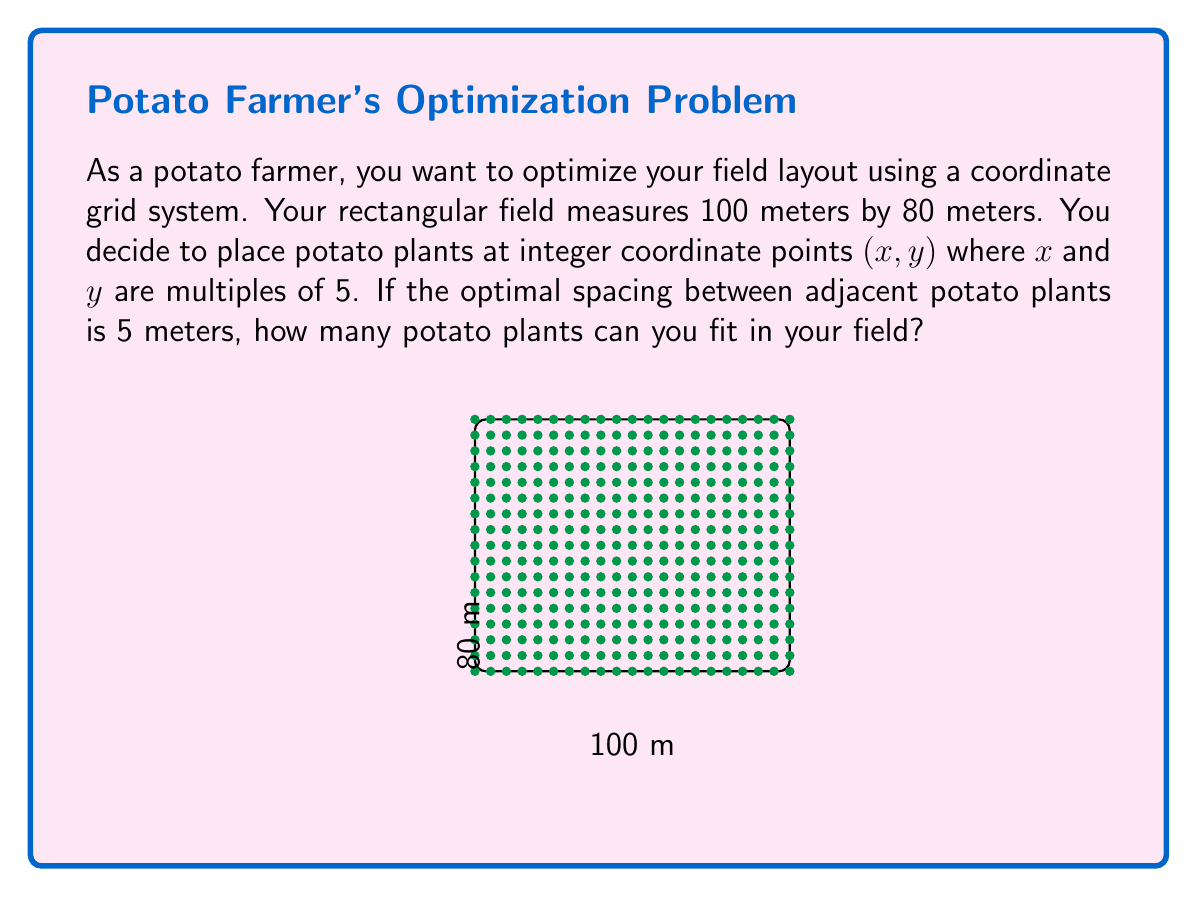Teach me how to tackle this problem. Let's approach this step-by-step:

1) First, we need to determine how many rows and columns of potato plants we can fit in the field.

2) For the x-axis (100 meters):
   - The plants will be at 0, 5, 10, 15, ..., 95, 100 meters
   - Number of x-coordinates = $\frac{100}{5} + 1 = 21$

3) For the y-axis (80 meters):
   - The plants will be at 0, 5, 10, 15, ..., 75, 80 meters
   - Number of y-coordinates = $\frac{80}{5} + 1 = 17$

4) The total number of potato plants will be the product of the number of x-coordinates and y-coordinates:

   $$\text{Total plants} = 21 \times 17$$

5) Calculate the result:
   $$\text{Total plants} = 21 \times 17 = 357$$

Therefore, you can fit 357 potato plants in your field with the given optimal spacing.
Answer: 357 potato plants 